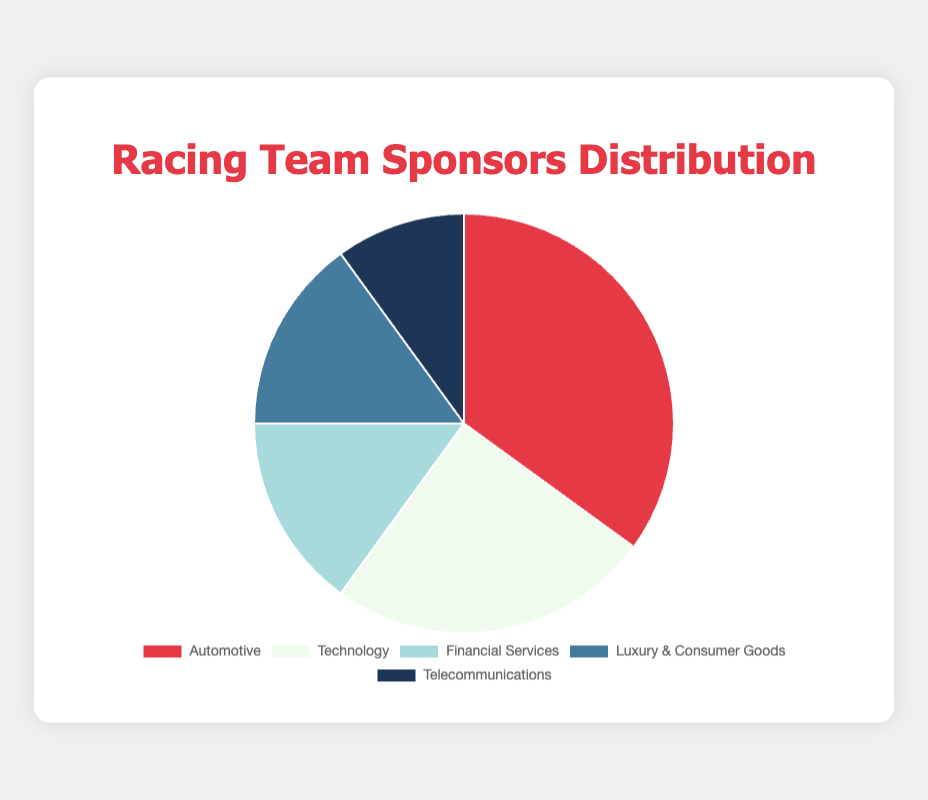Which industry has the largest percentage of racing team sponsors? According to the pie chart, the industry with the largest percentage is depicted by the segment that takes up the most space. This industry is labeled "Automotive."
Answer: Automotive Which industry has the smallest percentage of racing team sponsors? The pie chart shows that the smallest segment, which represents the smallest percentage, is labeled "Telecommunications."
Answer: Telecommunications What is the combined percentage of Racing Team sponsors from Financial Services and Luxury & Consumer Goods? To find the combined percentage, sum the percentages of Financial Services and Luxury & Consumer Goods. Each accounts for 15%, so 15% + 15% = 30%.
Answer: 30% Which two industries together account for more than 50% of the sponsors? By looking at the percentages, Automotive (35%) and Technology (25%) together make up 35% + 25% = 60%, which is more than 50%.
Answer: Automotive and Technology How much greater is the percentage of Automotive sponsors compared to Telecommunications sponsors? The percentage for Automotive is 35%, and for Telecommunications, it is 10%. The difference is 35% - 10% = 25%.
Answer: 25% Which industry segments are represented by light colors in the pie chart? Observing the color shading on the pie chart, the light colors can be noted. Here, they are Technology (white) and Financial Services (light blue).
Answer: Technology and Financial Services If you were to combine the segments representing Technology and Telecommunications into one new segment, what color combination would this segment likely represent based on the existing chart colors? The Technology segment is white, and Telecommunications segment is dark blue. The combination could be a gradient or mix of white and dark blue hues.
Answer: White and dark blue gradient What is the total percentage represented by the top three industries? The top three industries by percentage are Automotive (35%), Technology (25%), and both Financial Services and Luxury & Consumer Goods (tied at 15%). Summing the top three gives: 35% + 25% + 15% = 75%.
Answer: 75% How many more percentage points do Technology sponsors have compared to Financial Services sponsors? Technology accounts for 25% while Financial Services accounts for 15%. The difference is 25% - 15% = 10%.
Answer: 10% Which industries combined make up exactly half of the pie chart's total percentage? Financial Services (15%) and Luxury & Consumer Goods (15%) together are 30%, and adding Telecommunications (10%) totals 15% + 15% + 10% = 40%. Another combination would be: Financial Services (15%) + Luxury & Consumer Goods (15%) + Telecommunications (10%) + 10% from either Automotive or Technology doesn't sum to exactly 50%. However, Automotive (35%) + Telecommunications (10%) reaches only 45%. It's impossible to find an exact match without splitting into smaller percentages.
Answer: None 